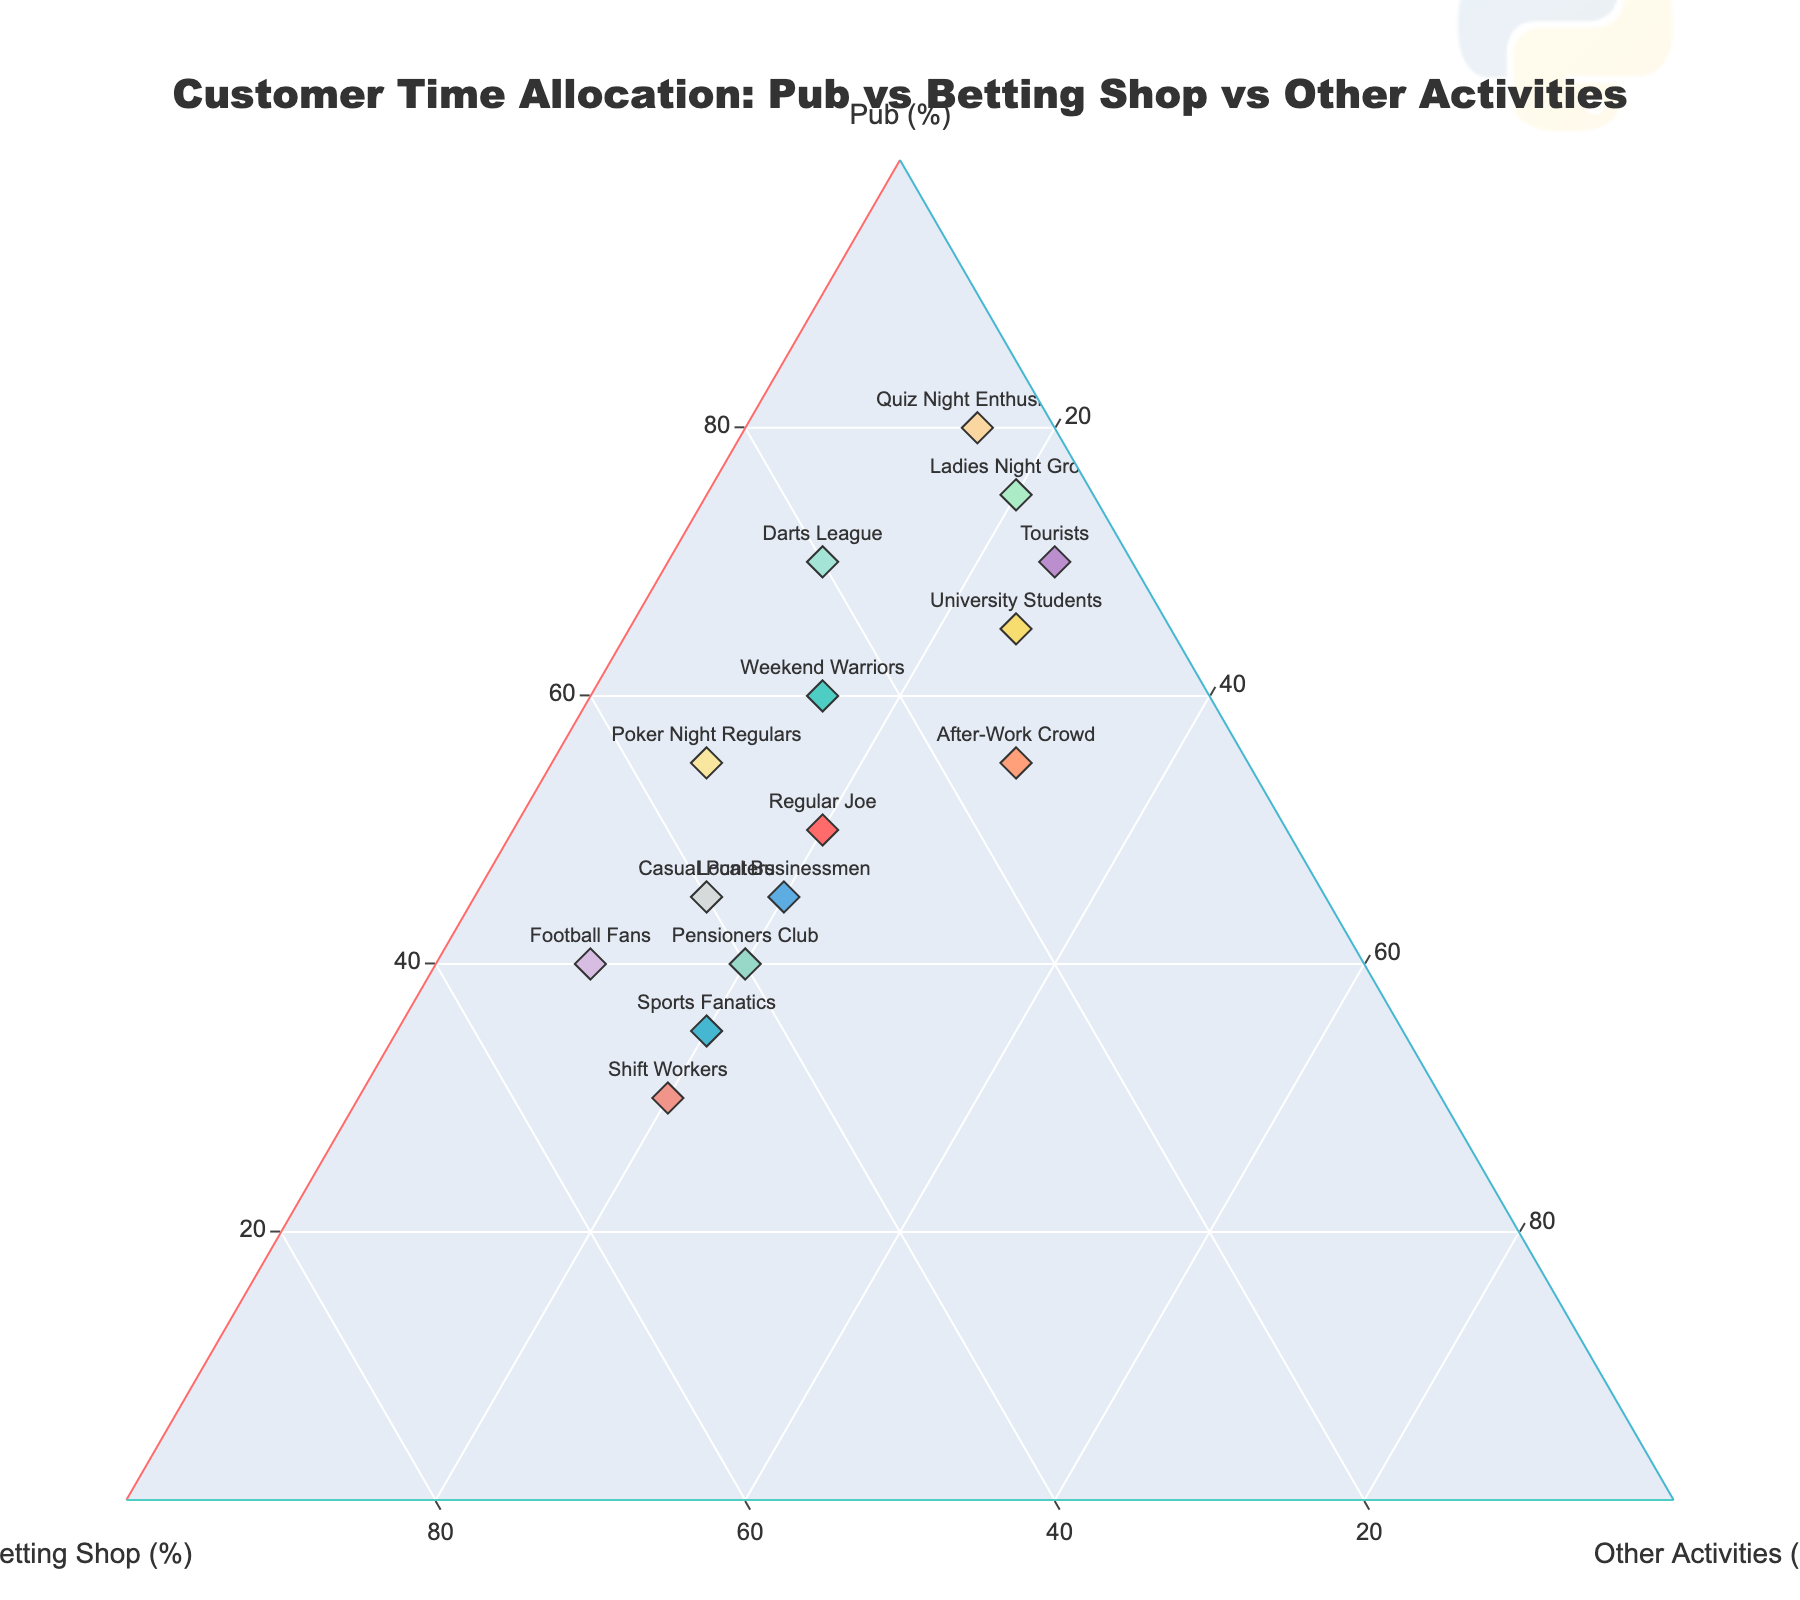What is the title of the figure? The title is located at the top of the figure and is usually one of the most noticeable textual elements. It provides a summary of what the figure represents.
Answer: Customer Time Allocation: Pub vs Betting Shop vs Other Activities Which customer group spends the most time at the pub? To find this, look for the point closest to the axis labeled "Pub (%)". The text label on this point indicates the customer group.
Answer: Quiz Night Enthusiasts Which customer group splits their time evenly between the pub and betting shop? To identify this group, look for a point equidistant from the "Pub (%)" and "Betting Shop (%)" axes. The text label on this point indicates the customer group.
Answer: Pensioners Club How many customer groups spend less than 15% of their time on other activities? Count the number of points situated closest to the "Pub (%)" and "Betting Shop (%)" axes and verify that their respective percentages for "Other Activities (%)" are less than 15%.
Answer: Four groups Which two customer groups have the highest time allocation at the betting shop? Look for the two points closest to the "Betting Shop (%)" axis. Check their text labels to identify the customer groups.
Answer: Football Fans and Shift Workers Who spends more time at the pub: Regular Joe or After-Work Crowd? Compare the positions of Regular Joe and After-Work Crowd along the "Pub (%)" axis. The closer point to this axis spends more time in the pub.
Answer: After-Work Crowd What is the combined percentage of time that Weekend Warriors and Tourists spend on other activities? Add the percentages from each data point for Weekend Warriors and Tourists, as indicated on the "Other Activities (%)" axis.
Answer: 40% Which customer group allocates the least time to betting (Betting Shop) and more to other activities? Look for the point nearest to the "Other Activities (%)" axis but farthest from the "Betting Shop (%)" axis. This indicates minimal betting time and maximal other activities.
Answer: Tourists 